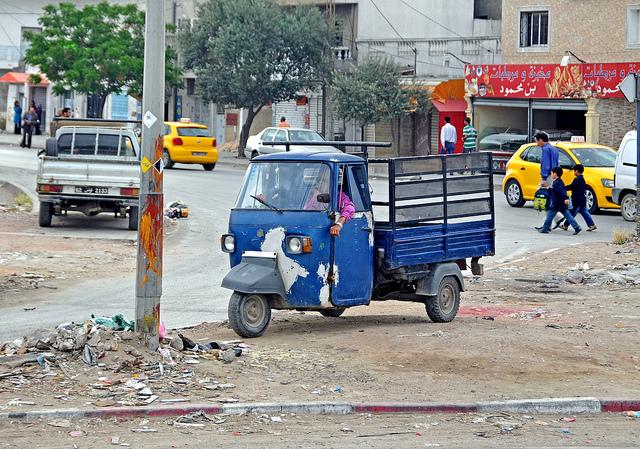How fast does the blue vehicle go?
Write a very short answer. Slow. What color is the vehicle beside the man and children?
Concise answer only. Yellow. What color is the vehicle?
Give a very brief answer. Blue. Are there people in the photo?
Answer briefly. Yes. 